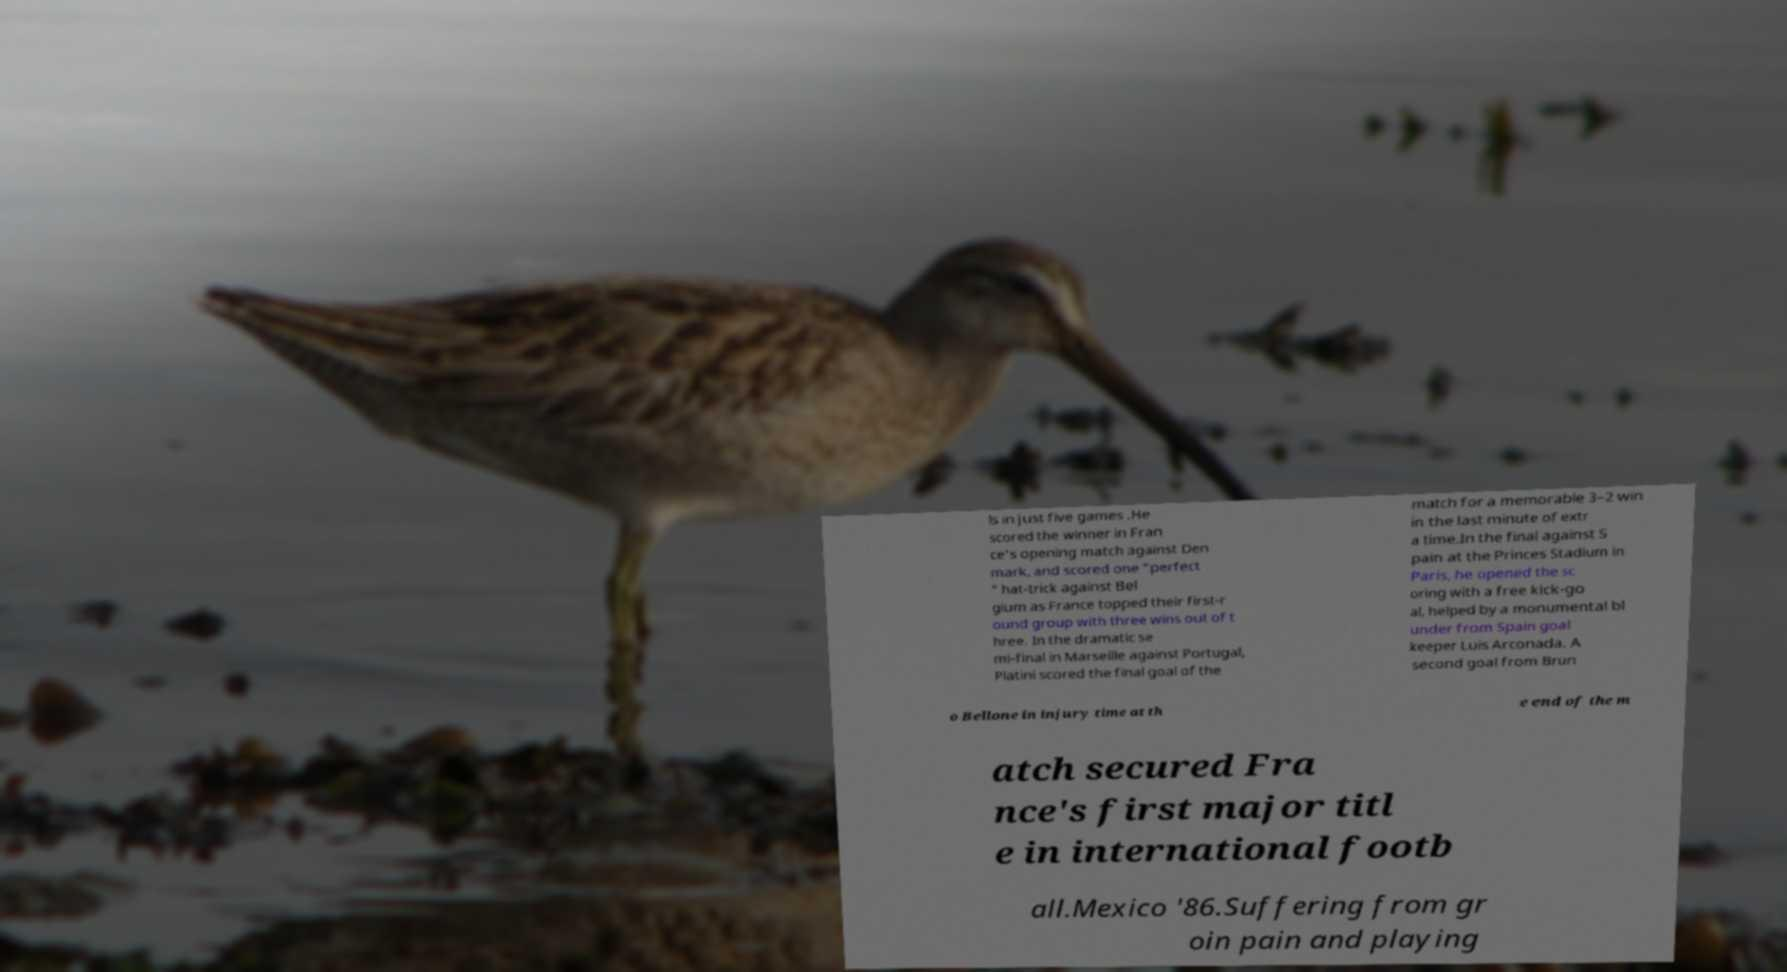Can you accurately transcribe the text from the provided image for me? ls in just five games .He scored the winner in Fran ce's opening match against Den mark, and scored one "perfect " hat-trick against Bel gium as France topped their first-r ound group with three wins out of t hree. In the dramatic se mi-final in Marseille against Portugal, Platini scored the final goal of the match for a memorable 3–2 win in the last minute of extr a time.In the final against S pain at the Princes Stadium in Paris, he opened the sc oring with a free kick-go al, helped by a monumental bl under from Spain goal keeper Luis Arconada. A second goal from Brun o Bellone in injury time at th e end of the m atch secured Fra nce's first major titl e in international footb all.Mexico '86.Suffering from gr oin pain and playing 